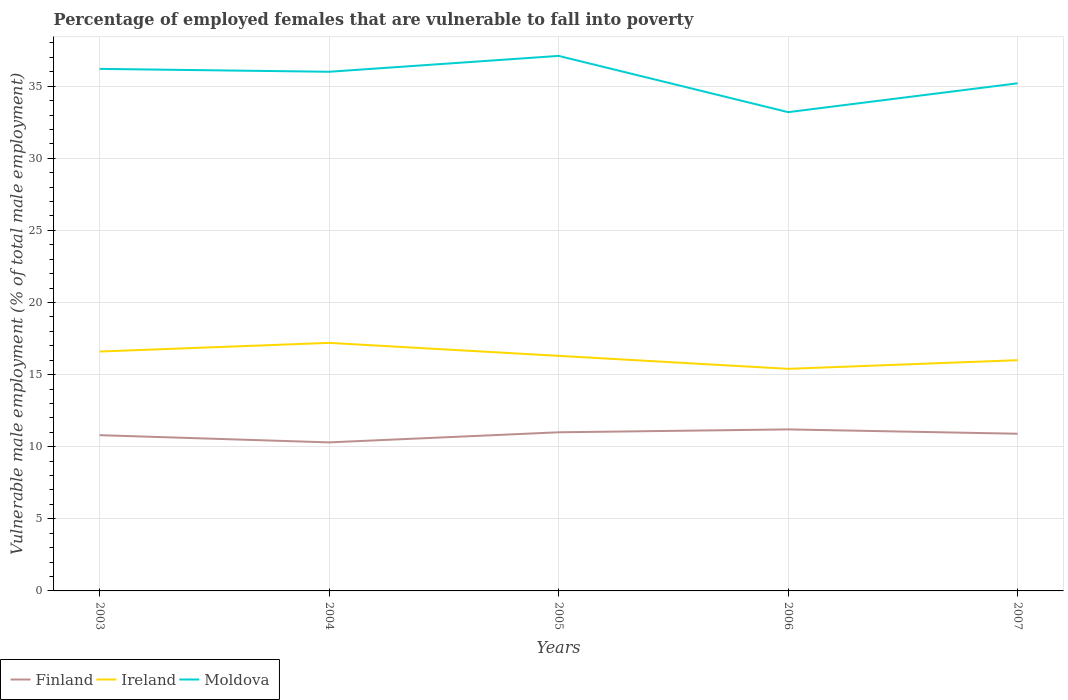Does the line corresponding to Finland intersect with the line corresponding to Ireland?
Ensure brevity in your answer.  No. Across all years, what is the maximum percentage of employed females who are vulnerable to fall into poverty in Finland?
Your response must be concise. 10.3. In which year was the percentage of employed females who are vulnerable to fall into poverty in Ireland maximum?
Your answer should be compact. 2006. What is the total percentage of employed females who are vulnerable to fall into poverty in Ireland in the graph?
Give a very brief answer. -0.6. What is the difference between the highest and the second highest percentage of employed females who are vulnerable to fall into poverty in Ireland?
Make the answer very short. 1.8. How many lines are there?
Your answer should be compact. 3. How many years are there in the graph?
Offer a terse response. 5. Are the values on the major ticks of Y-axis written in scientific E-notation?
Your answer should be very brief. No. Does the graph contain any zero values?
Your response must be concise. No. How are the legend labels stacked?
Make the answer very short. Horizontal. What is the title of the graph?
Keep it short and to the point. Percentage of employed females that are vulnerable to fall into poverty. What is the label or title of the Y-axis?
Make the answer very short. Vulnerable male employment (% of total male employment). What is the Vulnerable male employment (% of total male employment) in Finland in 2003?
Ensure brevity in your answer.  10.8. What is the Vulnerable male employment (% of total male employment) of Ireland in 2003?
Provide a short and direct response. 16.6. What is the Vulnerable male employment (% of total male employment) in Moldova in 2003?
Your answer should be compact. 36.2. What is the Vulnerable male employment (% of total male employment) in Finland in 2004?
Your answer should be very brief. 10.3. What is the Vulnerable male employment (% of total male employment) in Ireland in 2004?
Provide a short and direct response. 17.2. What is the Vulnerable male employment (% of total male employment) of Finland in 2005?
Your response must be concise. 11. What is the Vulnerable male employment (% of total male employment) in Ireland in 2005?
Provide a succinct answer. 16.3. What is the Vulnerable male employment (% of total male employment) in Moldova in 2005?
Provide a succinct answer. 37.1. What is the Vulnerable male employment (% of total male employment) of Finland in 2006?
Your response must be concise. 11.2. What is the Vulnerable male employment (% of total male employment) in Ireland in 2006?
Give a very brief answer. 15.4. What is the Vulnerable male employment (% of total male employment) of Moldova in 2006?
Make the answer very short. 33.2. What is the Vulnerable male employment (% of total male employment) in Finland in 2007?
Make the answer very short. 10.9. What is the Vulnerable male employment (% of total male employment) in Ireland in 2007?
Your answer should be compact. 16. What is the Vulnerable male employment (% of total male employment) of Moldova in 2007?
Provide a succinct answer. 35.2. Across all years, what is the maximum Vulnerable male employment (% of total male employment) of Finland?
Your response must be concise. 11.2. Across all years, what is the maximum Vulnerable male employment (% of total male employment) of Ireland?
Ensure brevity in your answer.  17.2. Across all years, what is the maximum Vulnerable male employment (% of total male employment) of Moldova?
Your answer should be very brief. 37.1. Across all years, what is the minimum Vulnerable male employment (% of total male employment) of Finland?
Provide a succinct answer. 10.3. Across all years, what is the minimum Vulnerable male employment (% of total male employment) in Ireland?
Keep it short and to the point. 15.4. Across all years, what is the minimum Vulnerable male employment (% of total male employment) in Moldova?
Provide a short and direct response. 33.2. What is the total Vulnerable male employment (% of total male employment) in Finland in the graph?
Provide a succinct answer. 54.2. What is the total Vulnerable male employment (% of total male employment) of Ireland in the graph?
Ensure brevity in your answer.  81.5. What is the total Vulnerable male employment (% of total male employment) of Moldova in the graph?
Make the answer very short. 177.7. What is the difference between the Vulnerable male employment (% of total male employment) of Finland in 2003 and that in 2004?
Your response must be concise. 0.5. What is the difference between the Vulnerable male employment (% of total male employment) in Moldova in 2003 and that in 2004?
Ensure brevity in your answer.  0.2. What is the difference between the Vulnerable male employment (% of total male employment) in Finland in 2003 and that in 2006?
Ensure brevity in your answer.  -0.4. What is the difference between the Vulnerable male employment (% of total male employment) of Ireland in 2003 and that in 2006?
Your response must be concise. 1.2. What is the difference between the Vulnerable male employment (% of total male employment) of Finland in 2003 and that in 2007?
Offer a terse response. -0.1. What is the difference between the Vulnerable male employment (% of total male employment) of Moldova in 2003 and that in 2007?
Your answer should be very brief. 1. What is the difference between the Vulnerable male employment (% of total male employment) in Finland in 2004 and that in 2005?
Offer a terse response. -0.7. What is the difference between the Vulnerable male employment (% of total male employment) in Moldova in 2004 and that in 2005?
Your answer should be compact. -1.1. What is the difference between the Vulnerable male employment (% of total male employment) in Ireland in 2004 and that in 2006?
Provide a short and direct response. 1.8. What is the difference between the Vulnerable male employment (% of total male employment) in Finland in 2005 and that in 2007?
Offer a very short reply. 0.1. What is the difference between the Vulnerable male employment (% of total male employment) of Ireland in 2005 and that in 2007?
Offer a very short reply. 0.3. What is the difference between the Vulnerable male employment (% of total male employment) of Finland in 2006 and that in 2007?
Provide a succinct answer. 0.3. What is the difference between the Vulnerable male employment (% of total male employment) of Ireland in 2006 and that in 2007?
Ensure brevity in your answer.  -0.6. What is the difference between the Vulnerable male employment (% of total male employment) of Finland in 2003 and the Vulnerable male employment (% of total male employment) of Ireland in 2004?
Keep it short and to the point. -6.4. What is the difference between the Vulnerable male employment (% of total male employment) in Finland in 2003 and the Vulnerable male employment (% of total male employment) in Moldova in 2004?
Provide a succinct answer. -25.2. What is the difference between the Vulnerable male employment (% of total male employment) of Ireland in 2003 and the Vulnerable male employment (% of total male employment) of Moldova in 2004?
Your response must be concise. -19.4. What is the difference between the Vulnerable male employment (% of total male employment) of Finland in 2003 and the Vulnerable male employment (% of total male employment) of Moldova in 2005?
Provide a short and direct response. -26.3. What is the difference between the Vulnerable male employment (% of total male employment) of Ireland in 2003 and the Vulnerable male employment (% of total male employment) of Moldova in 2005?
Provide a short and direct response. -20.5. What is the difference between the Vulnerable male employment (% of total male employment) in Finland in 2003 and the Vulnerable male employment (% of total male employment) in Moldova in 2006?
Ensure brevity in your answer.  -22.4. What is the difference between the Vulnerable male employment (% of total male employment) in Ireland in 2003 and the Vulnerable male employment (% of total male employment) in Moldova in 2006?
Your response must be concise. -16.6. What is the difference between the Vulnerable male employment (% of total male employment) of Finland in 2003 and the Vulnerable male employment (% of total male employment) of Moldova in 2007?
Your answer should be very brief. -24.4. What is the difference between the Vulnerable male employment (% of total male employment) in Ireland in 2003 and the Vulnerable male employment (% of total male employment) in Moldova in 2007?
Ensure brevity in your answer.  -18.6. What is the difference between the Vulnerable male employment (% of total male employment) of Finland in 2004 and the Vulnerable male employment (% of total male employment) of Ireland in 2005?
Offer a terse response. -6. What is the difference between the Vulnerable male employment (% of total male employment) of Finland in 2004 and the Vulnerable male employment (% of total male employment) of Moldova in 2005?
Offer a terse response. -26.8. What is the difference between the Vulnerable male employment (% of total male employment) of Ireland in 2004 and the Vulnerable male employment (% of total male employment) of Moldova in 2005?
Offer a terse response. -19.9. What is the difference between the Vulnerable male employment (% of total male employment) of Finland in 2004 and the Vulnerable male employment (% of total male employment) of Moldova in 2006?
Your response must be concise. -22.9. What is the difference between the Vulnerable male employment (% of total male employment) in Ireland in 2004 and the Vulnerable male employment (% of total male employment) in Moldova in 2006?
Ensure brevity in your answer.  -16. What is the difference between the Vulnerable male employment (% of total male employment) in Finland in 2004 and the Vulnerable male employment (% of total male employment) in Ireland in 2007?
Keep it short and to the point. -5.7. What is the difference between the Vulnerable male employment (% of total male employment) of Finland in 2004 and the Vulnerable male employment (% of total male employment) of Moldova in 2007?
Provide a succinct answer. -24.9. What is the difference between the Vulnerable male employment (% of total male employment) in Finland in 2005 and the Vulnerable male employment (% of total male employment) in Ireland in 2006?
Your answer should be very brief. -4.4. What is the difference between the Vulnerable male employment (% of total male employment) of Finland in 2005 and the Vulnerable male employment (% of total male employment) of Moldova in 2006?
Your answer should be compact. -22.2. What is the difference between the Vulnerable male employment (% of total male employment) in Ireland in 2005 and the Vulnerable male employment (% of total male employment) in Moldova in 2006?
Your response must be concise. -16.9. What is the difference between the Vulnerable male employment (% of total male employment) in Finland in 2005 and the Vulnerable male employment (% of total male employment) in Ireland in 2007?
Your response must be concise. -5. What is the difference between the Vulnerable male employment (% of total male employment) of Finland in 2005 and the Vulnerable male employment (% of total male employment) of Moldova in 2007?
Make the answer very short. -24.2. What is the difference between the Vulnerable male employment (% of total male employment) of Ireland in 2005 and the Vulnerable male employment (% of total male employment) of Moldova in 2007?
Make the answer very short. -18.9. What is the difference between the Vulnerable male employment (% of total male employment) of Finland in 2006 and the Vulnerable male employment (% of total male employment) of Moldova in 2007?
Provide a short and direct response. -24. What is the difference between the Vulnerable male employment (% of total male employment) of Ireland in 2006 and the Vulnerable male employment (% of total male employment) of Moldova in 2007?
Your response must be concise. -19.8. What is the average Vulnerable male employment (% of total male employment) of Finland per year?
Provide a short and direct response. 10.84. What is the average Vulnerable male employment (% of total male employment) of Ireland per year?
Your answer should be compact. 16.3. What is the average Vulnerable male employment (% of total male employment) in Moldova per year?
Your answer should be compact. 35.54. In the year 2003, what is the difference between the Vulnerable male employment (% of total male employment) of Finland and Vulnerable male employment (% of total male employment) of Ireland?
Provide a succinct answer. -5.8. In the year 2003, what is the difference between the Vulnerable male employment (% of total male employment) in Finland and Vulnerable male employment (% of total male employment) in Moldova?
Provide a short and direct response. -25.4. In the year 2003, what is the difference between the Vulnerable male employment (% of total male employment) in Ireland and Vulnerable male employment (% of total male employment) in Moldova?
Offer a very short reply. -19.6. In the year 2004, what is the difference between the Vulnerable male employment (% of total male employment) in Finland and Vulnerable male employment (% of total male employment) in Ireland?
Your response must be concise. -6.9. In the year 2004, what is the difference between the Vulnerable male employment (% of total male employment) of Finland and Vulnerable male employment (% of total male employment) of Moldova?
Your answer should be very brief. -25.7. In the year 2004, what is the difference between the Vulnerable male employment (% of total male employment) in Ireland and Vulnerable male employment (% of total male employment) in Moldova?
Make the answer very short. -18.8. In the year 2005, what is the difference between the Vulnerable male employment (% of total male employment) in Finland and Vulnerable male employment (% of total male employment) in Moldova?
Your response must be concise. -26.1. In the year 2005, what is the difference between the Vulnerable male employment (% of total male employment) in Ireland and Vulnerable male employment (% of total male employment) in Moldova?
Give a very brief answer. -20.8. In the year 2006, what is the difference between the Vulnerable male employment (% of total male employment) in Finland and Vulnerable male employment (% of total male employment) in Ireland?
Offer a very short reply. -4.2. In the year 2006, what is the difference between the Vulnerable male employment (% of total male employment) of Ireland and Vulnerable male employment (% of total male employment) of Moldova?
Your answer should be compact. -17.8. In the year 2007, what is the difference between the Vulnerable male employment (% of total male employment) in Finland and Vulnerable male employment (% of total male employment) in Moldova?
Make the answer very short. -24.3. In the year 2007, what is the difference between the Vulnerable male employment (% of total male employment) of Ireland and Vulnerable male employment (% of total male employment) of Moldova?
Give a very brief answer. -19.2. What is the ratio of the Vulnerable male employment (% of total male employment) in Finland in 2003 to that in 2004?
Make the answer very short. 1.05. What is the ratio of the Vulnerable male employment (% of total male employment) in Ireland in 2003 to that in 2004?
Provide a succinct answer. 0.97. What is the ratio of the Vulnerable male employment (% of total male employment) of Moldova in 2003 to that in 2004?
Ensure brevity in your answer.  1.01. What is the ratio of the Vulnerable male employment (% of total male employment) of Finland in 2003 to that in 2005?
Ensure brevity in your answer.  0.98. What is the ratio of the Vulnerable male employment (% of total male employment) in Ireland in 2003 to that in 2005?
Your answer should be very brief. 1.02. What is the ratio of the Vulnerable male employment (% of total male employment) in Moldova in 2003 to that in 2005?
Keep it short and to the point. 0.98. What is the ratio of the Vulnerable male employment (% of total male employment) of Finland in 2003 to that in 2006?
Keep it short and to the point. 0.96. What is the ratio of the Vulnerable male employment (% of total male employment) in Ireland in 2003 to that in 2006?
Provide a short and direct response. 1.08. What is the ratio of the Vulnerable male employment (% of total male employment) of Moldova in 2003 to that in 2006?
Provide a succinct answer. 1.09. What is the ratio of the Vulnerable male employment (% of total male employment) in Ireland in 2003 to that in 2007?
Keep it short and to the point. 1.04. What is the ratio of the Vulnerable male employment (% of total male employment) of Moldova in 2003 to that in 2007?
Offer a very short reply. 1.03. What is the ratio of the Vulnerable male employment (% of total male employment) in Finland in 2004 to that in 2005?
Give a very brief answer. 0.94. What is the ratio of the Vulnerable male employment (% of total male employment) in Ireland in 2004 to that in 2005?
Provide a short and direct response. 1.06. What is the ratio of the Vulnerable male employment (% of total male employment) of Moldova in 2004 to that in 2005?
Offer a terse response. 0.97. What is the ratio of the Vulnerable male employment (% of total male employment) of Finland in 2004 to that in 2006?
Offer a terse response. 0.92. What is the ratio of the Vulnerable male employment (% of total male employment) of Ireland in 2004 to that in 2006?
Give a very brief answer. 1.12. What is the ratio of the Vulnerable male employment (% of total male employment) in Moldova in 2004 to that in 2006?
Keep it short and to the point. 1.08. What is the ratio of the Vulnerable male employment (% of total male employment) of Finland in 2004 to that in 2007?
Provide a succinct answer. 0.94. What is the ratio of the Vulnerable male employment (% of total male employment) in Ireland in 2004 to that in 2007?
Your response must be concise. 1.07. What is the ratio of the Vulnerable male employment (% of total male employment) of Moldova in 2004 to that in 2007?
Provide a short and direct response. 1.02. What is the ratio of the Vulnerable male employment (% of total male employment) in Finland in 2005 to that in 2006?
Give a very brief answer. 0.98. What is the ratio of the Vulnerable male employment (% of total male employment) in Ireland in 2005 to that in 2006?
Your answer should be compact. 1.06. What is the ratio of the Vulnerable male employment (% of total male employment) in Moldova in 2005 to that in 2006?
Keep it short and to the point. 1.12. What is the ratio of the Vulnerable male employment (% of total male employment) of Finland in 2005 to that in 2007?
Provide a short and direct response. 1.01. What is the ratio of the Vulnerable male employment (% of total male employment) of Ireland in 2005 to that in 2007?
Offer a terse response. 1.02. What is the ratio of the Vulnerable male employment (% of total male employment) in Moldova in 2005 to that in 2007?
Your response must be concise. 1.05. What is the ratio of the Vulnerable male employment (% of total male employment) of Finland in 2006 to that in 2007?
Provide a short and direct response. 1.03. What is the ratio of the Vulnerable male employment (% of total male employment) of Ireland in 2006 to that in 2007?
Ensure brevity in your answer.  0.96. What is the ratio of the Vulnerable male employment (% of total male employment) of Moldova in 2006 to that in 2007?
Provide a short and direct response. 0.94. What is the difference between the highest and the second highest Vulnerable male employment (% of total male employment) in Finland?
Your answer should be very brief. 0.2. 